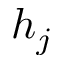Convert formula to latex. <formula><loc_0><loc_0><loc_500><loc_500>h _ { j }</formula> 